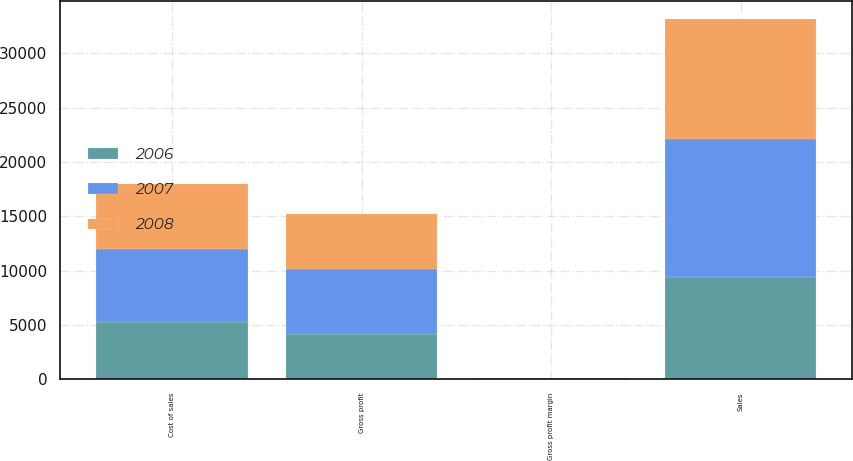Convert chart to OTSL. <chart><loc_0><loc_0><loc_500><loc_500><stacked_bar_chart><ecel><fcel>Sales<fcel>Cost of sales<fcel>Gross profit<fcel>Gross profit margin<nl><fcel>2007<fcel>12697.5<fcel>6757.3<fcel>5940.2<fcel>46.8<nl><fcel>2008<fcel>11025.9<fcel>5985<fcel>5040.9<fcel>45.7<nl><fcel>2006<fcel>9466.1<fcel>5269<fcel>4197.1<fcel>44.3<nl></chart> 